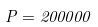<formula> <loc_0><loc_0><loc_500><loc_500>P = 2 0 0 0 0 0</formula> 